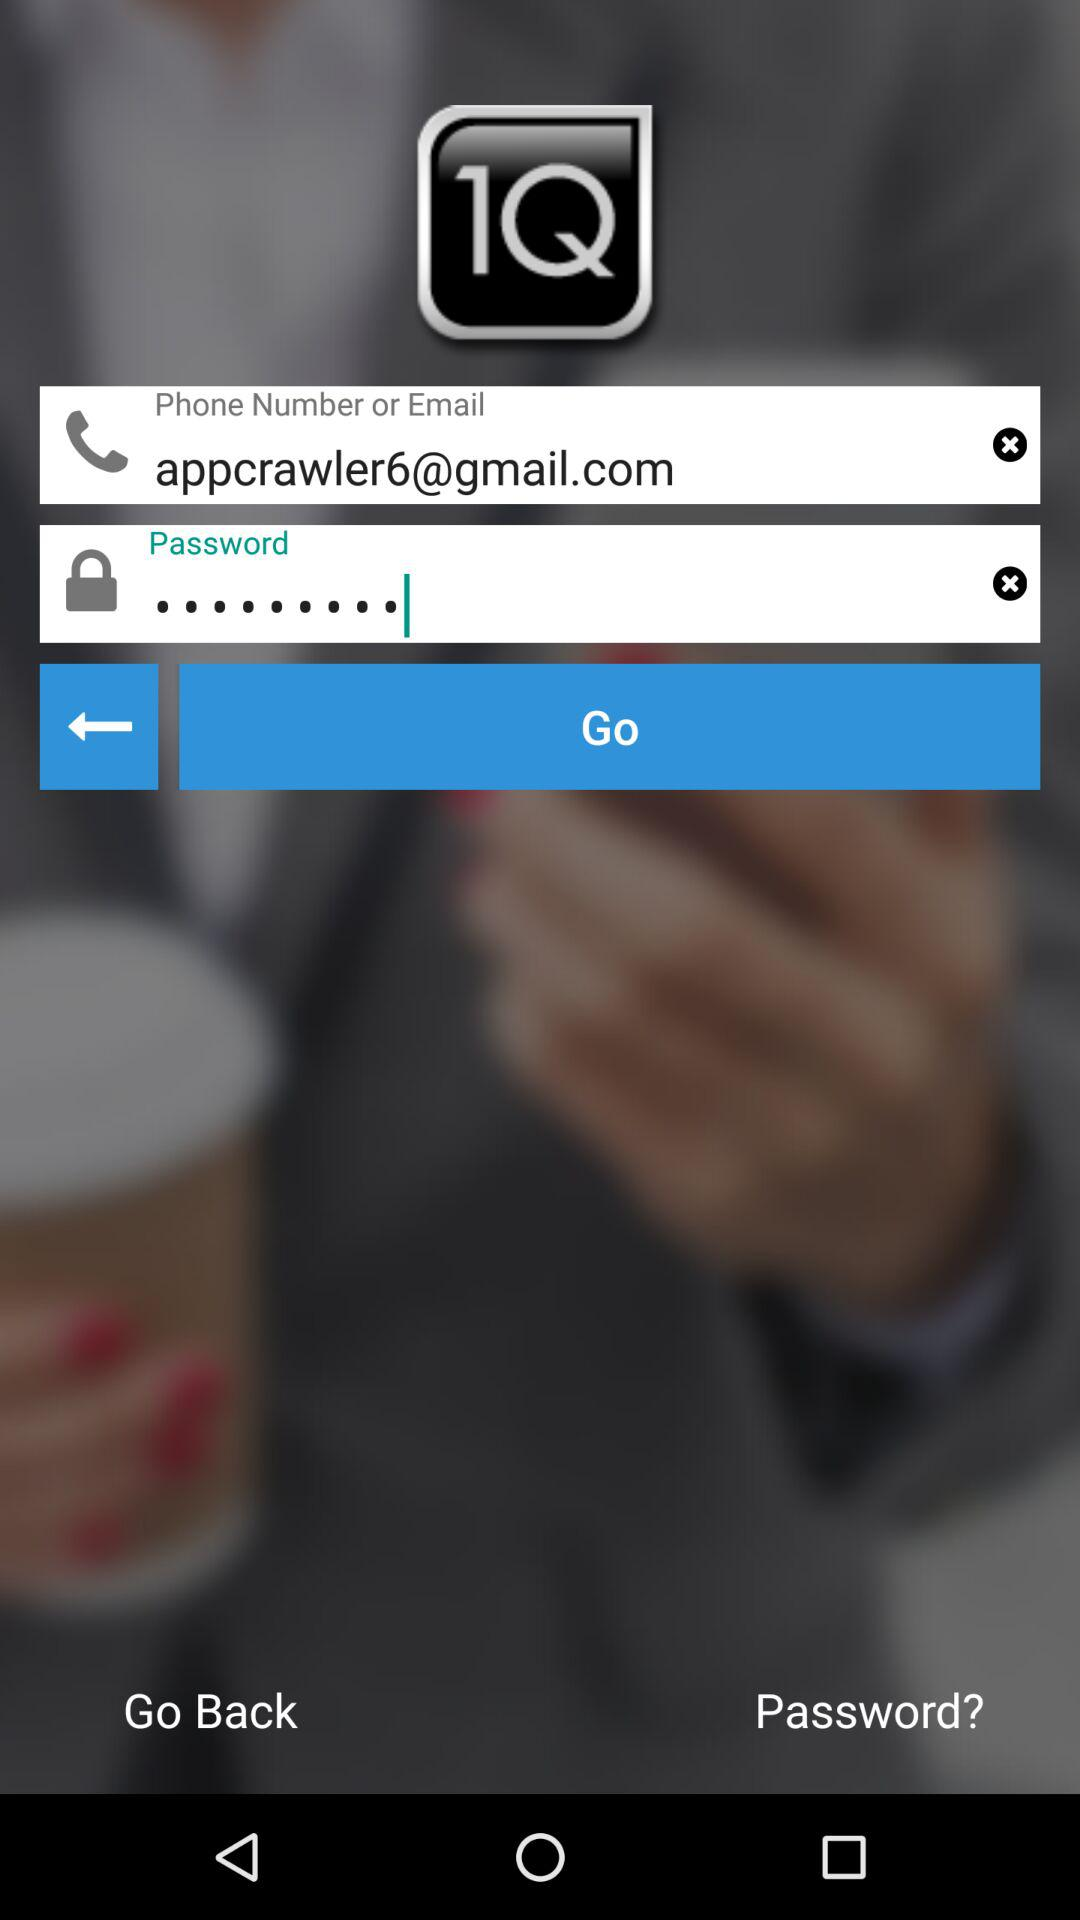What is the email address of the user? The email address of the user is appcrawler6@gmail.com. 